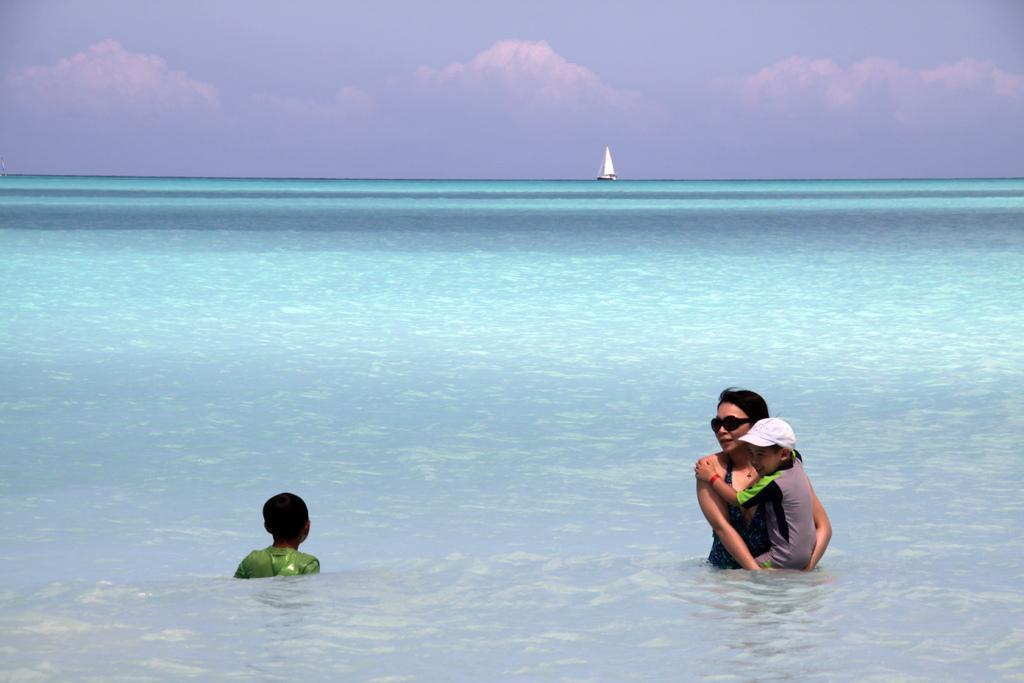Please provide a concise description of this image. Far there is a boat. Sky is cloudy. Here we can see water and people. 